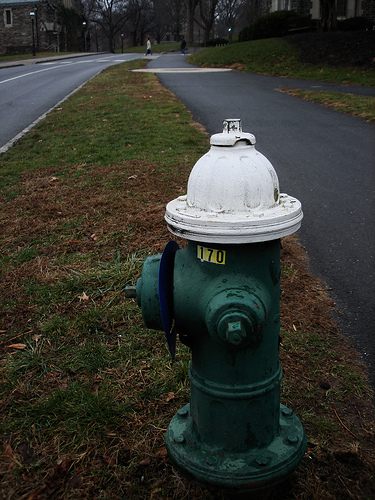Describe the overall environment depicted in the image. The image features a residential street lined with bare trees and a visible fire hydrant in the foreground. It appears to be a cloudy day, lending a tranquil yet desolate feel to the scene. What might be the significance of the fire hydrant's color in this setting? The green color of the fire hydrant could indicate the available water flow rate or pressure, typically a coding method used by municipal services to aid firefighters during emergencies. 